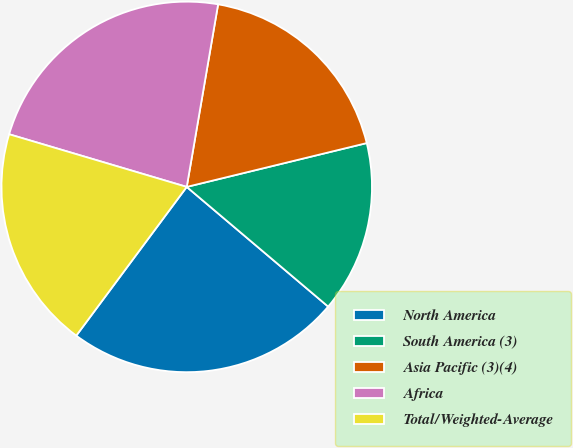Convert chart. <chart><loc_0><loc_0><loc_500><loc_500><pie_chart><fcel>North America<fcel>South America (3)<fcel>Asia Pacific (3)(4)<fcel>Africa<fcel>Total/Weighted-Average<nl><fcel>23.99%<fcel>14.98%<fcel>18.49%<fcel>23.12%<fcel>19.42%<nl></chart> 